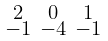Convert formula to latex. <formula><loc_0><loc_0><loc_500><loc_500>\begin{smallmatrix} 2 & 0 & 1 \\ - 1 & - 4 & - 1 \end{smallmatrix}</formula> 